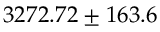<formula> <loc_0><loc_0><loc_500><loc_500>3 2 7 2 . 7 2 \pm 1 6 3 . 6</formula> 